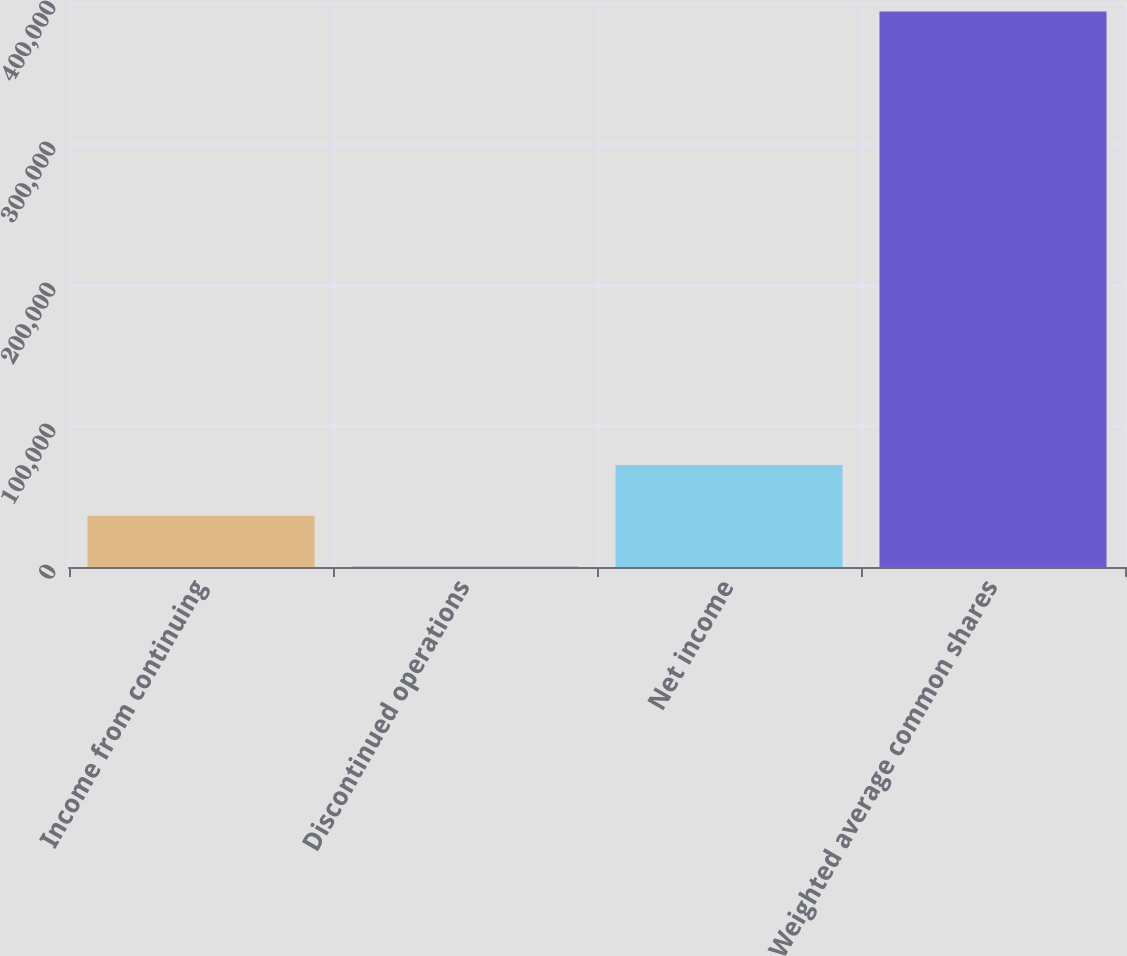Convert chart. <chart><loc_0><loc_0><loc_500><loc_500><bar_chart><fcel>Income from continuing<fcel>Discontinued operations<fcel>Net income<fcel>Weighted average common shares<nl><fcel>36352<fcel>277<fcel>72427<fcel>393986<nl></chart> 